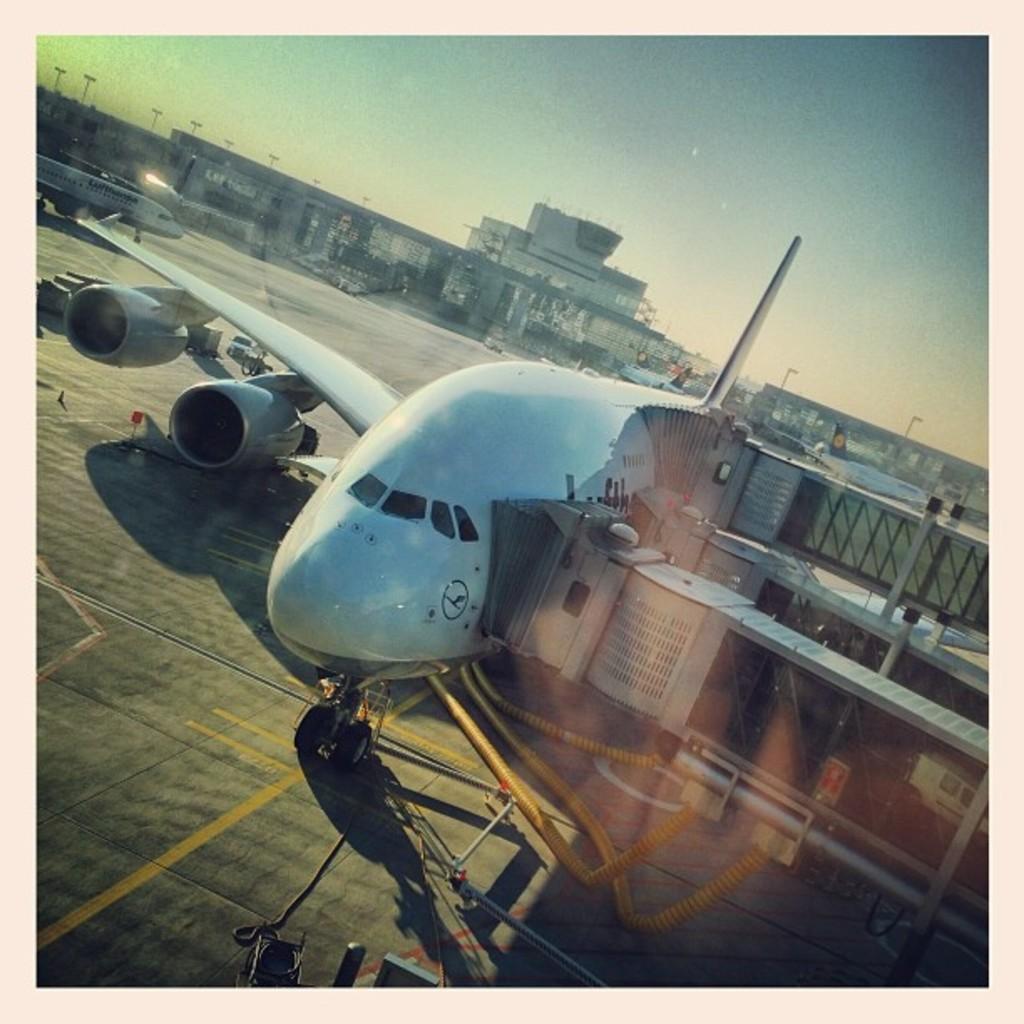How would you summarize this image in a sentence or two? This picture consists of aircraft, a vehicle on the right side, in the middle there is a building, in front of building there is aircraft and poles, at the top there is the sky. 